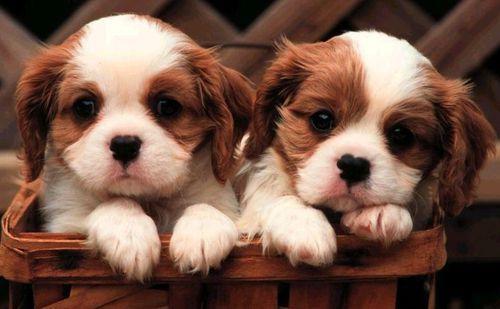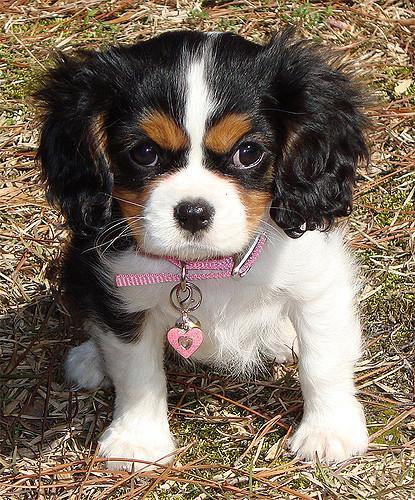The first image is the image on the left, the second image is the image on the right. Considering the images on both sides, is "There are at most two dogs." valid? Answer yes or no. No. The first image is the image on the left, the second image is the image on the right. For the images shown, is this caption "There are exactly two Cavalier King Charles puppies on the pair of images." true? Answer yes or no. No. 